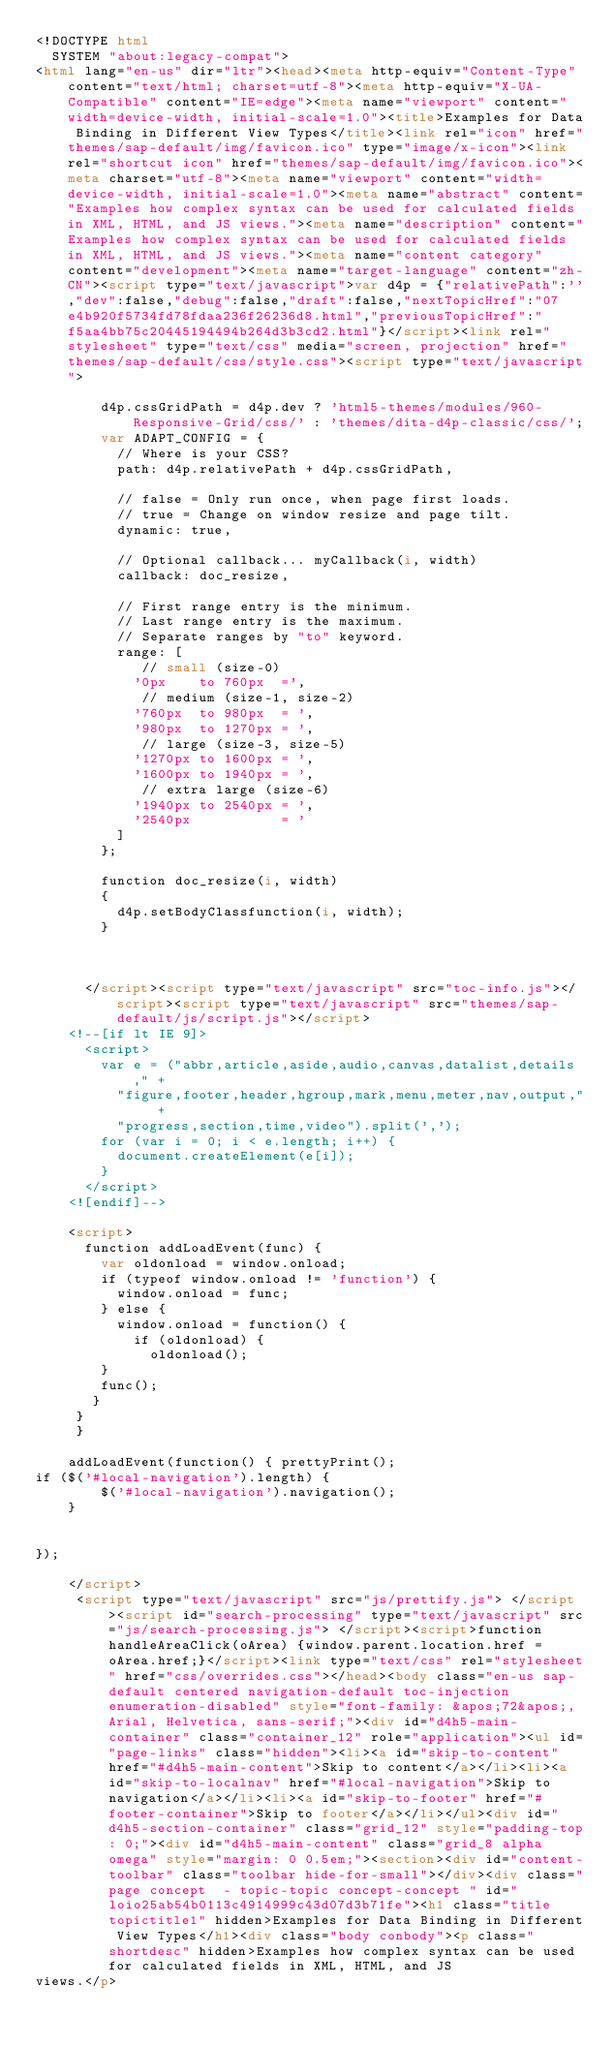Convert code to text. <code><loc_0><loc_0><loc_500><loc_500><_HTML_><!DOCTYPE html
  SYSTEM "about:legacy-compat">
<html lang="en-us" dir="ltr"><head><meta http-equiv="Content-Type" content="text/html; charset=utf-8"><meta http-equiv="X-UA-Compatible" content="IE=edge"><meta name="viewport" content="width=device-width, initial-scale=1.0"><title>Examples for Data Binding in Different View Types</title><link rel="icon" href="themes/sap-default/img/favicon.ico" type="image/x-icon"><link rel="shortcut icon" href="themes/sap-default/img/favicon.ico"><meta charset="utf-8"><meta name="viewport" content="width=device-width, initial-scale=1.0"><meta name="abstract" content="Examples how complex syntax can be used for calculated fields in XML, HTML, and JS views."><meta name="description" content="Examples how complex syntax can be used for calculated fields in XML, HTML, and JS views."><meta name="content category" content="development"><meta name="target-language" content="zh-CN"><script type="text/javascript">var d4p = {"relativePath":'',"dev":false,"debug":false,"draft":false,"nextTopicHref":"07e4b920f5734fd78fdaa236f26236d8.html","previousTopicHref":"f5aa4bb75c20445194494b264d3b3cd2.html"}</script><link rel="stylesheet" type="text/css" media="screen, projection" href="themes/sap-default/css/style.css"><script type="text/javascript">
      
        d4p.cssGridPath = d4p.dev ? 'html5-themes/modules/960-Responsive-Grid/css/' : 'themes/dita-d4p-classic/css/';
        var ADAPT_CONFIG = {
          // Where is your CSS?
          path: d4p.relativePath + d4p.cssGridPath,

          // false = Only run once, when page first loads.
          // true = Change on window resize and page tilt.
          dynamic: true,

          // Optional callback... myCallback(i, width)
          callback: doc_resize,

          // First range entry is the minimum.
          // Last range entry is the maximum.
          // Separate ranges by "to" keyword.
          range: [
             // small (size-0)
            '0px    to 760px  =',
             // medium (size-1, size-2)
            '760px  to 980px  = ',
            '980px  to 1270px = ',
             // large (size-3, size-5)
            '1270px to 1600px = ',
            '1600px to 1940px = ',
             // extra large (size-6)
            '1940px to 2540px = ',
            '2540px           = '
          ]
        };

        function doc_resize(i, width)
        {
          d4p.setBodyClassfunction(i, width);
        }


        
      </script><script type="text/javascript" src="toc-info.js"></script><script type="text/javascript" src="themes/sap-default/js/script.js"></script>
		<!--[if lt IE 9]>
			<script>
			  var e = ("abbr,article,aside,audio,canvas,datalist,details," +
			    "figure,footer,header,hgroup,mark,menu,meter,nav,output," +
			    "progress,section,time,video").split(',');
			  for (var i = 0; i < e.length; i++) {
			    document.createElement(e[i]);
			  }
			</script>
		<![endif]-->
        
    <script>
      function addLoadEvent(func) {
        var oldonload = window.onload;
        if (typeof window.onload != 'function') {
          window.onload = func;
        } else {
          window.onload = function() {
            if (oldonload) {
              oldonload();
        }
        func();
       }
     }
     }
      
    addLoadEvent(function() { prettyPrint();
if ($('#local-navigation').length) {
        $('#local-navigation').navigation();
    }


});
      
    </script>
     <script type="text/javascript" src="js/prettify.js"> </script><script id="search-processing" type="text/javascript" src="js/search-processing.js"> </script><script>function handleAreaClick(oArea) {window.parent.location.href = oArea.href;}</script><link type="text/css" rel="stylesheet" href="css/overrides.css"></head><body class="en-us sap-default centered navigation-default toc-injection enumeration-disabled" style="font-family: &apos;72&apos;, Arial, Helvetica, sans-serif;"><div id="d4h5-main-container" class="container_12" role="application"><ul id="page-links" class="hidden"><li><a id="skip-to-content" href="#d4h5-main-content">Skip to content</a></li><li><a id="skip-to-localnav" href="#local-navigation">Skip to navigation</a></li><li><a id="skip-to-footer" href="#footer-container">Skip to footer</a></li></ul><div id="d4h5-section-container" class="grid_12" style="padding-top: 0;"><div id="d4h5-main-content" class="grid_8 alpha omega" style="margin: 0 0.5em;"><section><div id="content-toolbar" class="toolbar hide-for-small"></div><div class="page concept  - topic-topic concept-concept " id="loio25ab54b0113c4914999c43d07d3b71fe"><h1 class="title topictitle1" hidden>Examples for Data Binding in Different View Types</h1><div class="body conbody"><p class="shortdesc" hidden>Examples how complex syntax can be used for calculated fields in XML, HTML, and JS
views.</p></code> 